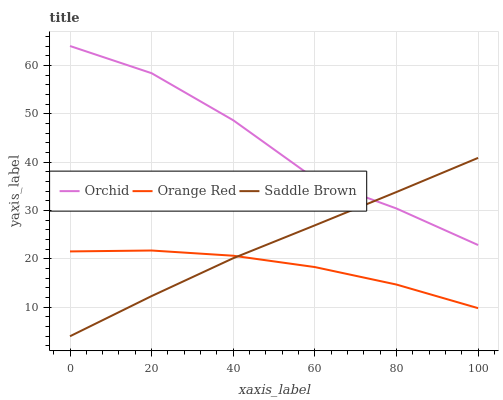Does Orange Red have the minimum area under the curve?
Answer yes or no. Yes. Does Orchid have the maximum area under the curve?
Answer yes or no. Yes. Does Orchid have the minimum area under the curve?
Answer yes or no. No. Does Orange Red have the maximum area under the curve?
Answer yes or no. No. Is Saddle Brown the smoothest?
Answer yes or no. Yes. Is Orchid the roughest?
Answer yes or no. Yes. Is Orange Red the smoothest?
Answer yes or no. No. Is Orange Red the roughest?
Answer yes or no. No. Does Orange Red have the lowest value?
Answer yes or no. No. Does Orchid have the highest value?
Answer yes or no. Yes. Does Orange Red have the highest value?
Answer yes or no. No. Is Orange Red less than Orchid?
Answer yes or no. Yes. Is Orchid greater than Orange Red?
Answer yes or no. Yes. Does Orange Red intersect Orchid?
Answer yes or no. No. 